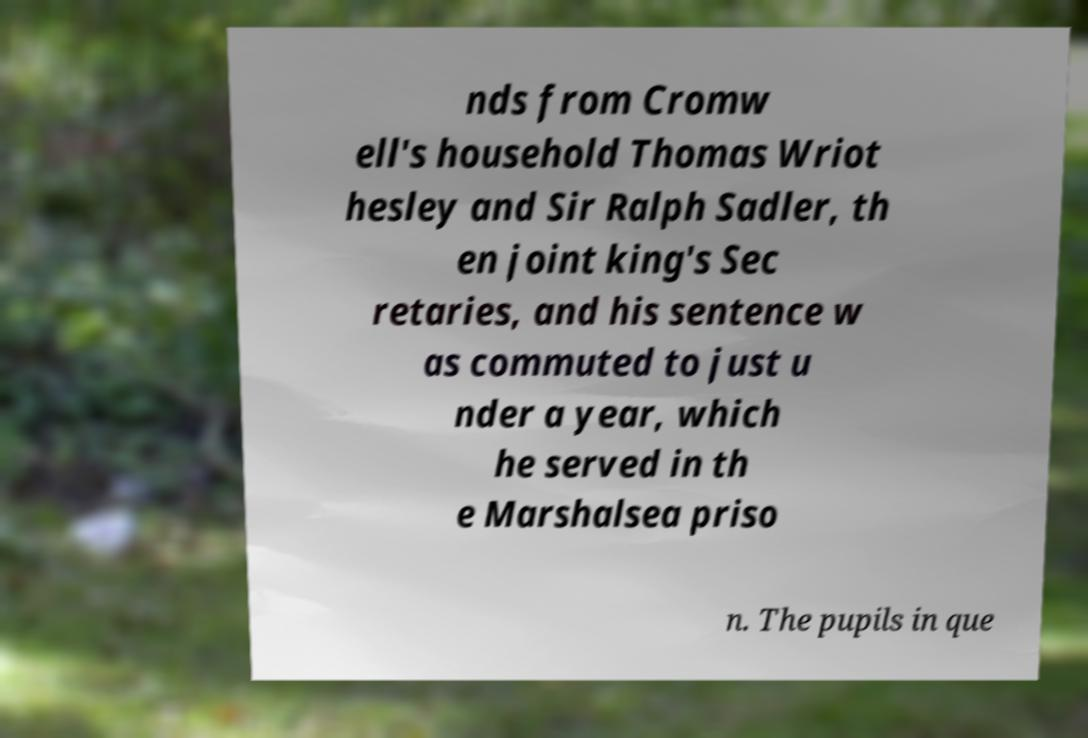Could you assist in decoding the text presented in this image and type it out clearly? nds from Cromw ell's household Thomas Wriot hesley and Sir Ralph Sadler, th en joint king's Sec retaries, and his sentence w as commuted to just u nder a year, which he served in th e Marshalsea priso n. The pupils in que 